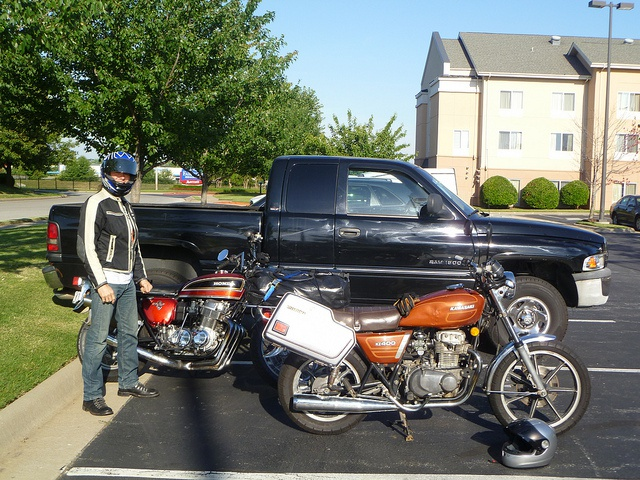Describe the objects in this image and their specific colors. I can see truck in green, black, gray, navy, and darkgray tones, motorcycle in green, gray, black, white, and darkgray tones, motorcycle in green, black, gray, white, and darkgray tones, people in green, gray, black, ivory, and darkgray tones, and car in green, black, and gray tones in this image. 